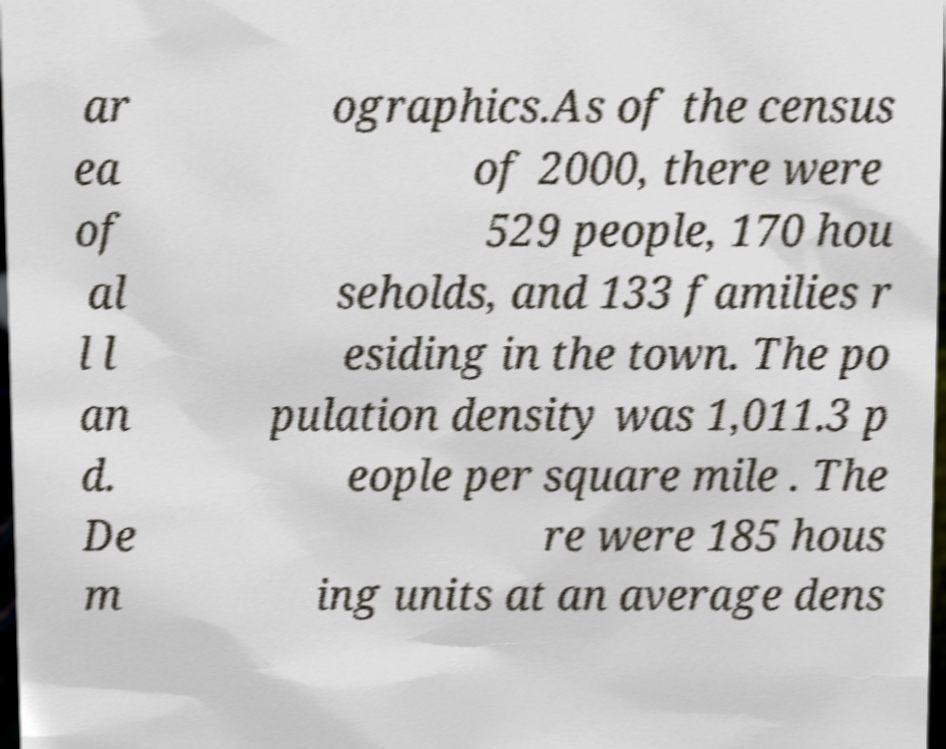I need the written content from this picture converted into text. Can you do that? ar ea of al l l an d. De m ographics.As of the census of 2000, there were 529 people, 170 hou seholds, and 133 families r esiding in the town. The po pulation density was 1,011.3 p eople per square mile . The re were 185 hous ing units at an average dens 